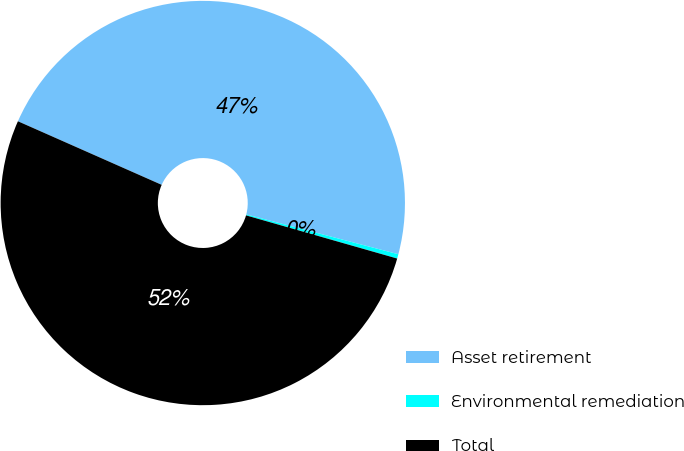Convert chart to OTSL. <chart><loc_0><loc_0><loc_500><loc_500><pie_chart><fcel>Asset retirement<fcel>Environmental remediation<fcel>Total<nl><fcel>47.45%<fcel>0.35%<fcel>52.2%<nl></chart> 